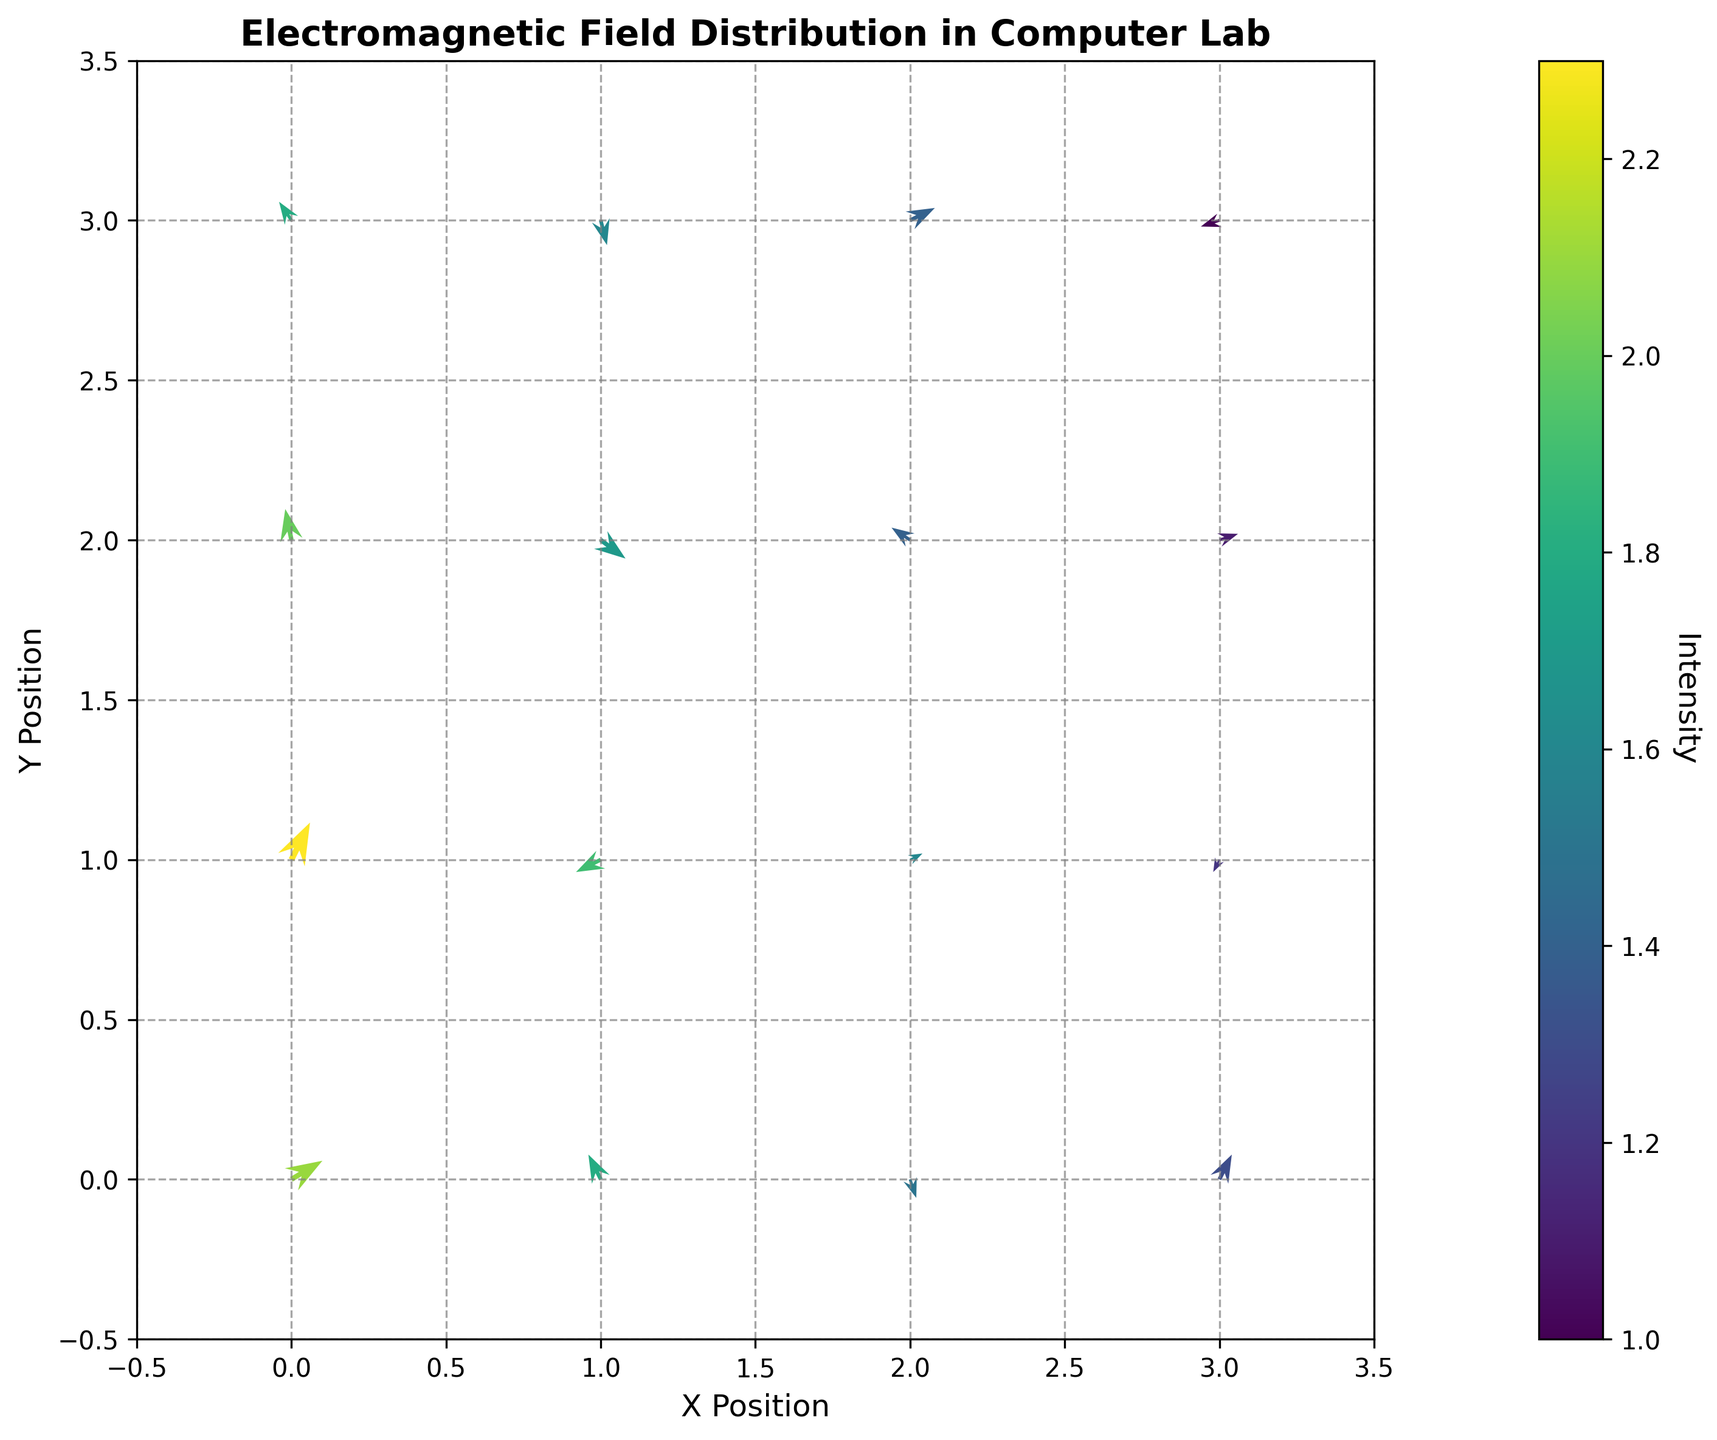What's the title of the figure? The title of the figure is displayed at the top center of the plot. It is usually a descriptive text summarizing the content of the plot.
Answer: Electromagnetic Field Distribution in Computer Lab How many data points are displayed in the figure? Count the number of arrows displayed in the quiver plot, each representing a data point.
Answer: 16 What is the range of the x-axis? Look at the x-axis label and identify the minimum and maximum values indicated on the axis.
Answer: -0.5 to 3.5 Which data point has the highest intensity? Observe the color of the arrows and refer to the colorbar legend. The arrow nearest to the highest color intensity represents the highest intensity value. The arrow at (0, 1) is the most intense based on its color.
Answer: (0, 1) What is the direction of the vector at position (1, 1)? Observe the direction of the arrow originating from the coordinates (1, 1). It points to the lower left.
Answer: Lower left Which data point has a vector pointing upwards? Look for arrows pointing mostly upwards by observing their direction. The one at (0, 1) is a clear example.
Answer: (0, 1) Is there any data point with a vector pointing directly to the right? Check all the arrows' directions to see if any point directly to the right. There is no arrow pointing exactly to the right.
Answer: No What is the average intensity of the vectors in the top row? Add the intensity values of the vectors in the top row (y=3) and divide by the number of points.
Answer: (1.8 + 1.6 + 1.4 + 1.0) / 4 = 1.45 Which position has the longest vector? The longest vector can be identified by the length of the arrow. The one at (0, 1) appears to be the longest.
Answer: (0, 1) Which position has the smallest vector magnitude? The smallest magnitude vector can be identified by the shortest arrow length. The one at (3, 2) appears to be the smallest.
Answer: (3, 2) Is there any potential interference zone indicated by high intensity values clustered together? Identify regions with multiple high-intensity vectors in close proximity. The vectors around (0, 0), (0, 1), and (0, 2) suggest a potential interference zone due to high intensity.
Answer: Yes, around (0, 0), (0, 1), (0, 2) 